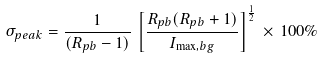Convert formula to latex. <formula><loc_0><loc_0><loc_500><loc_500>\sigma _ { p e a k } = \frac { 1 } { ( R _ { p b } - 1 ) } \, \left [ \frac { R _ { p b } ( R _ { p b } + 1 ) } { I _ { \max , b g } } \right ] ^ { \frac { 1 } { 2 } } \, \times \, 1 0 0 \%</formula> 